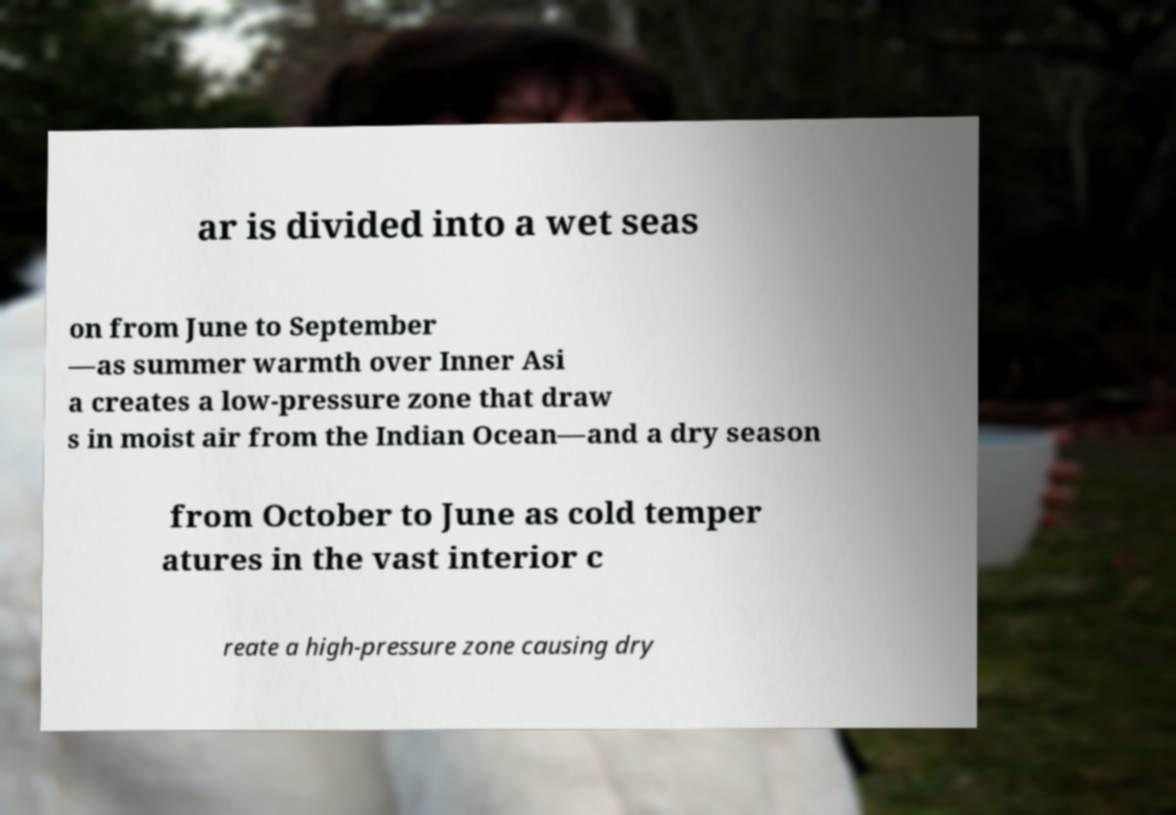Please read and relay the text visible in this image. What does it say? ar is divided into a wet seas on from June to September —as summer warmth over Inner Asi a creates a low-pressure zone that draw s in moist air from the Indian Ocean—and a dry season from October to June as cold temper atures in the vast interior c reate a high-pressure zone causing dry 